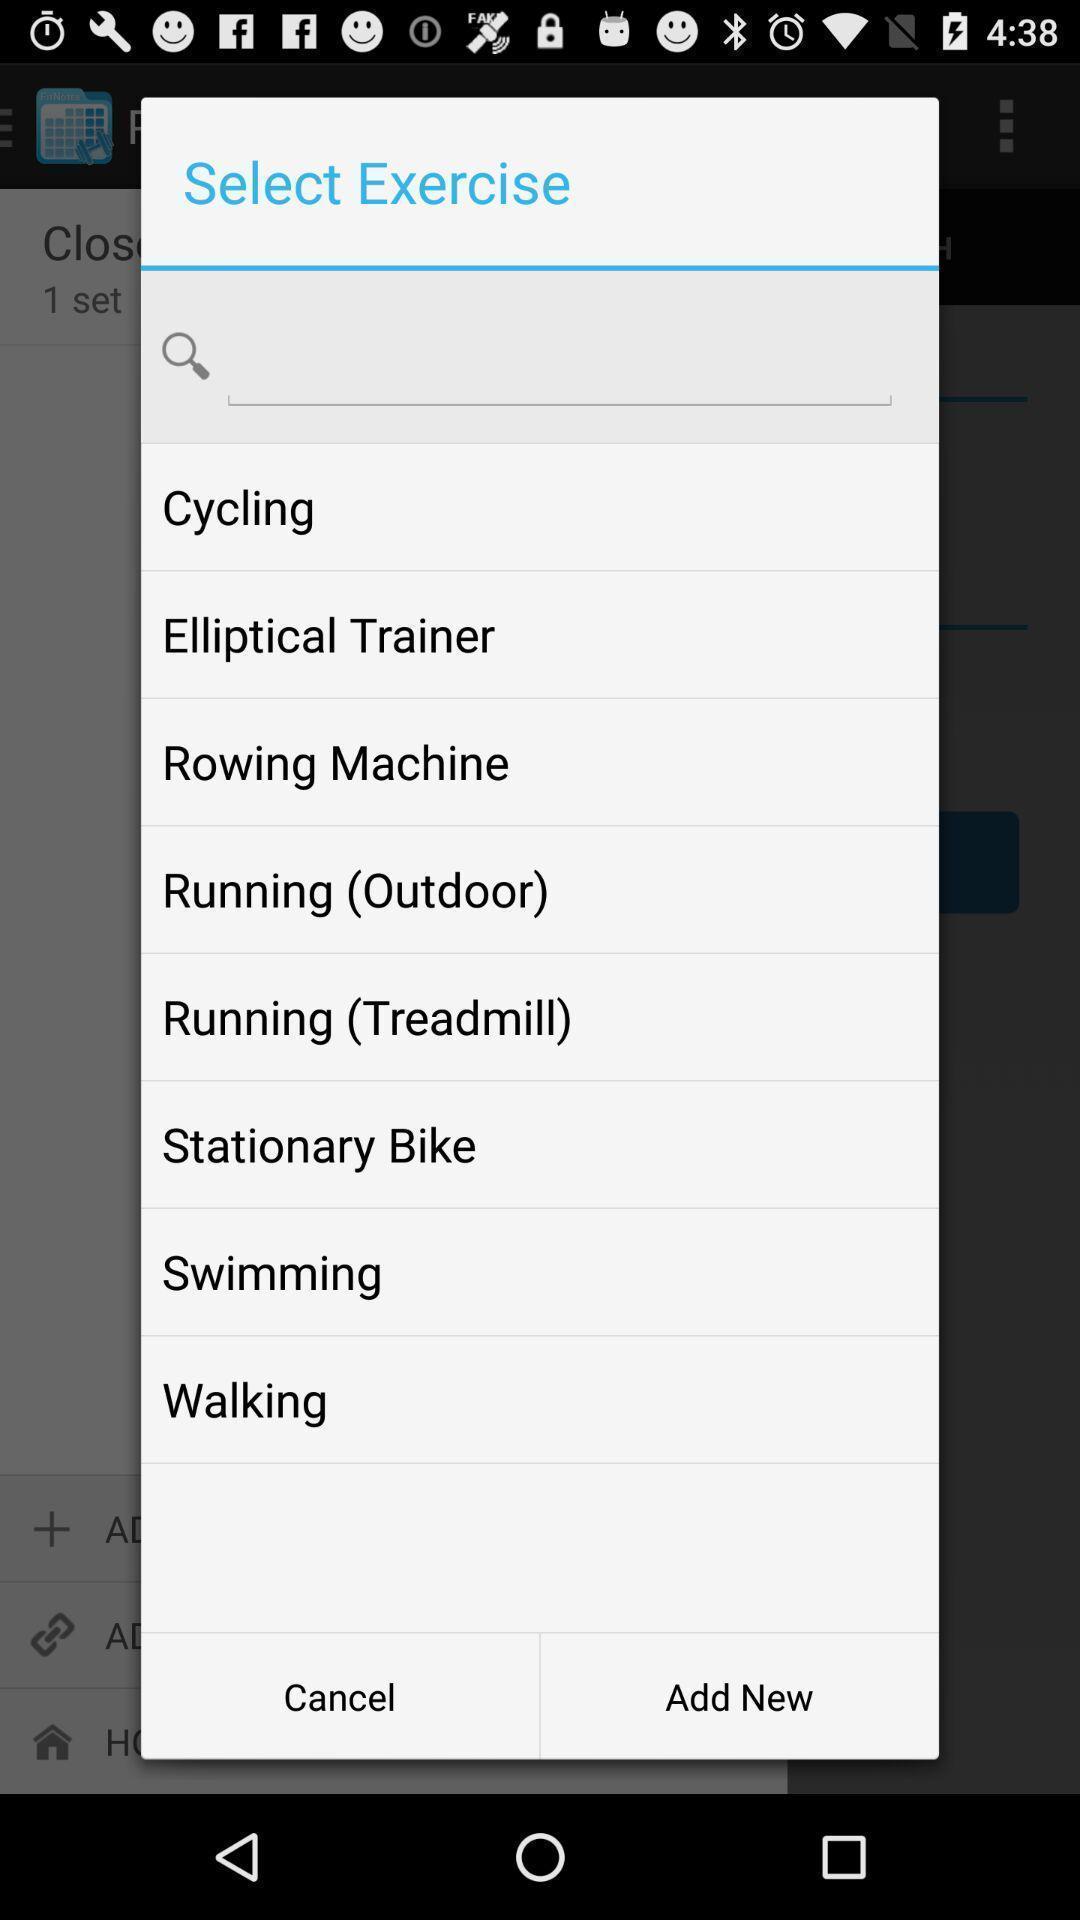What can you discern from this picture? Pop-up showing to select exercise. 